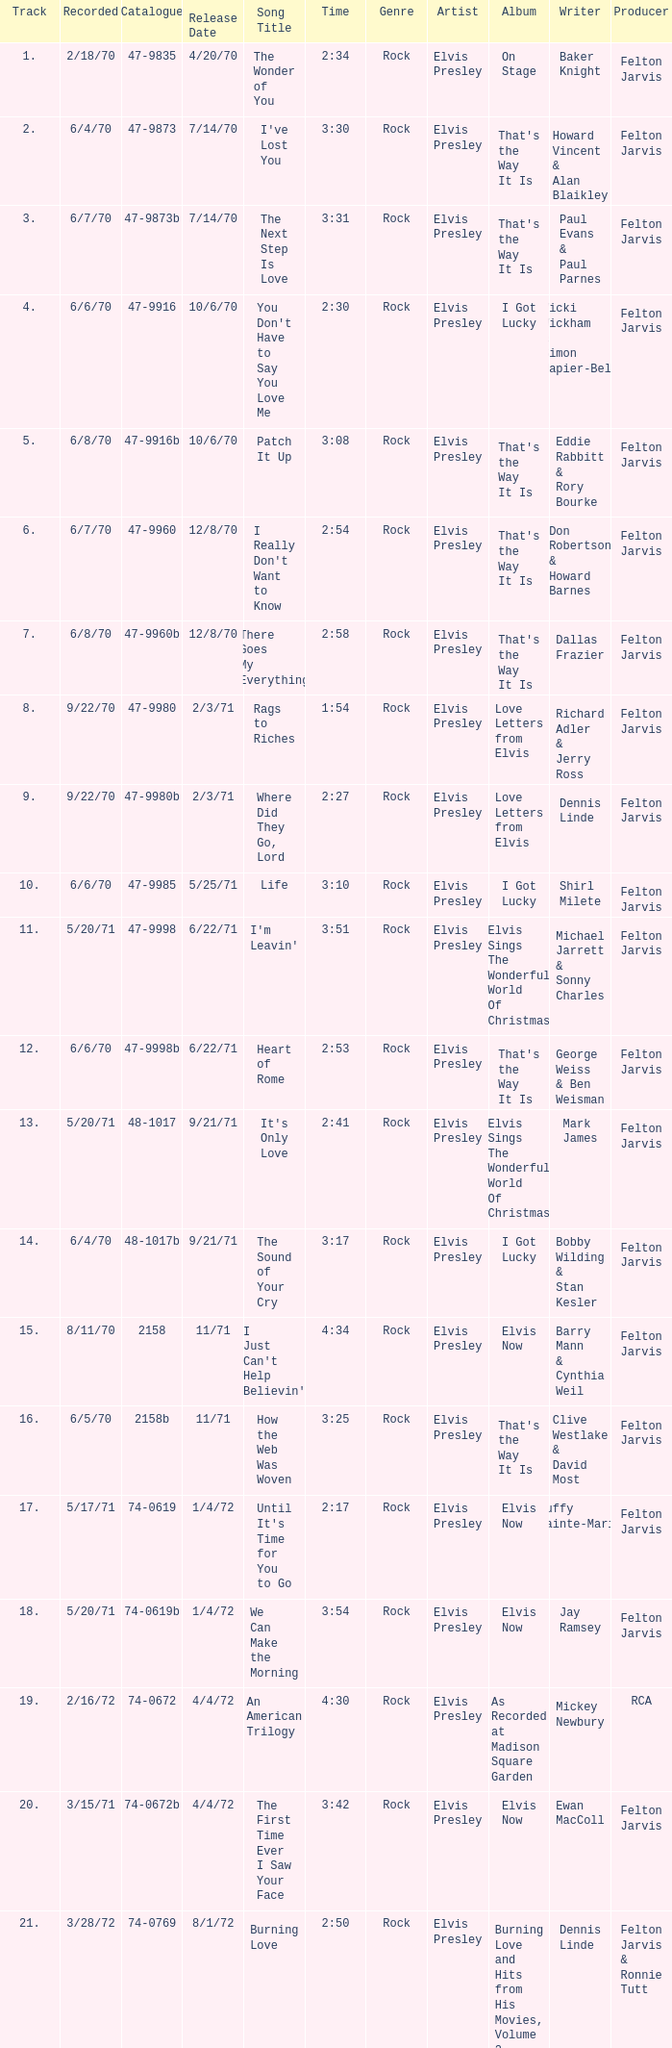Which song was released 12/8/70 with a time of 2:54? I Really Don't Want to Know. 